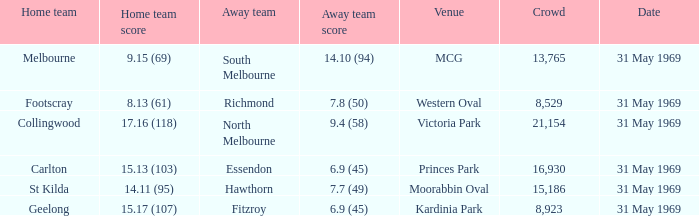Which home team scored 14.11 (95)? St Kilda. 